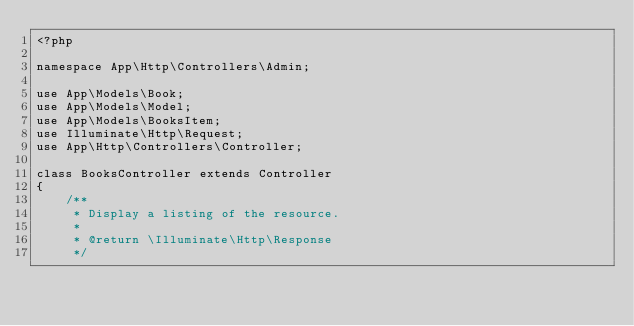Convert code to text. <code><loc_0><loc_0><loc_500><loc_500><_PHP_><?php

namespace App\Http\Controllers\Admin;

use App\Models\Book;
use App\Models\Model;
use App\Models\BooksItem;
use Illuminate\Http\Request;
use App\Http\Controllers\Controller;

class BooksController extends Controller
{
    /**
     * Display a listing of the resource.
     *
     * @return \Illuminate\Http\Response
     */</code> 